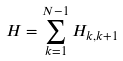<formula> <loc_0><loc_0><loc_500><loc_500>H = \sum _ { k = 1 } ^ { N - 1 } H _ { k , k + 1 }</formula> 